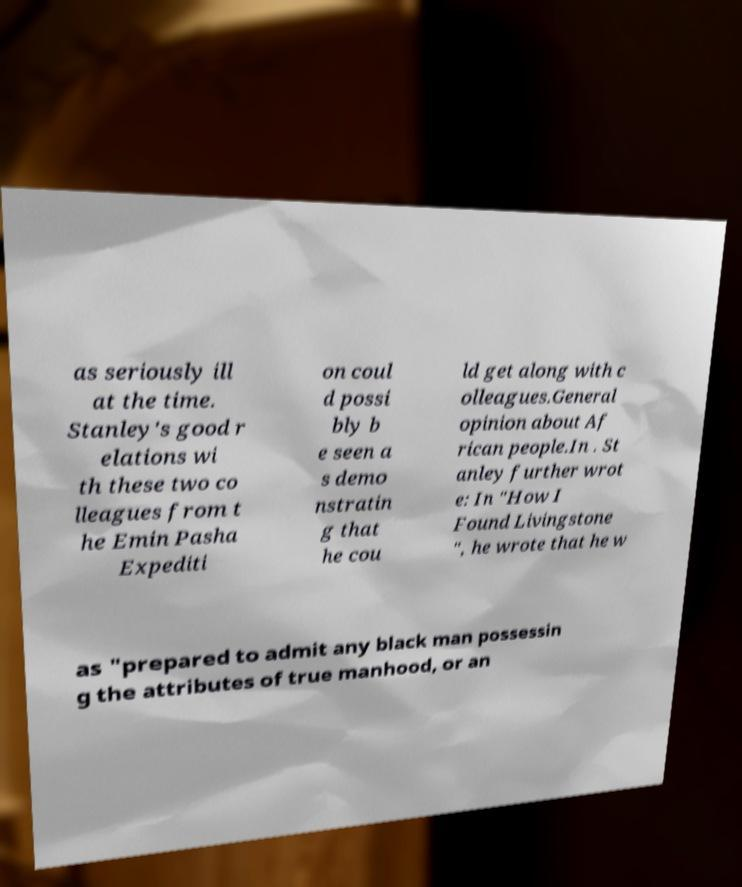There's text embedded in this image that I need extracted. Can you transcribe it verbatim? as seriously ill at the time. Stanley's good r elations wi th these two co lleagues from t he Emin Pasha Expediti on coul d possi bly b e seen a s demo nstratin g that he cou ld get along with c olleagues.General opinion about Af rican people.In . St anley further wrot e: In "How I Found Livingstone ", he wrote that he w as "prepared to admit any black man possessin g the attributes of true manhood, or an 